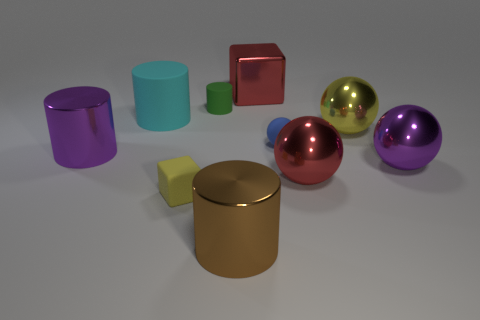Are there fewer large yellow objects in front of the big red metallic ball than small blue spheres in front of the blue thing?
Keep it short and to the point. No. What number of other objects are there of the same material as the brown thing?
Your answer should be compact. 5. Is the large purple sphere made of the same material as the yellow cube?
Your answer should be very brief. No. What number of other things are the same size as the red block?
Provide a short and direct response. 6. There is a red object that is behind the purple thing left of the cyan cylinder; how big is it?
Ensure brevity in your answer.  Large. There is a cube that is behind the red thing that is in front of the purple metal cylinder behind the tiny yellow rubber block; what color is it?
Give a very brief answer. Red. There is a object that is behind the big yellow metal ball and on the right side of the big brown cylinder; what size is it?
Your answer should be compact. Large. How many other objects are there of the same shape as the yellow rubber object?
Your response must be concise. 1. What number of spheres are either red shiny things or big cyan things?
Your response must be concise. 1. Is there a red shiny sphere left of the big red metal thing to the right of the large block to the right of the tiny green matte cylinder?
Offer a terse response. No. 